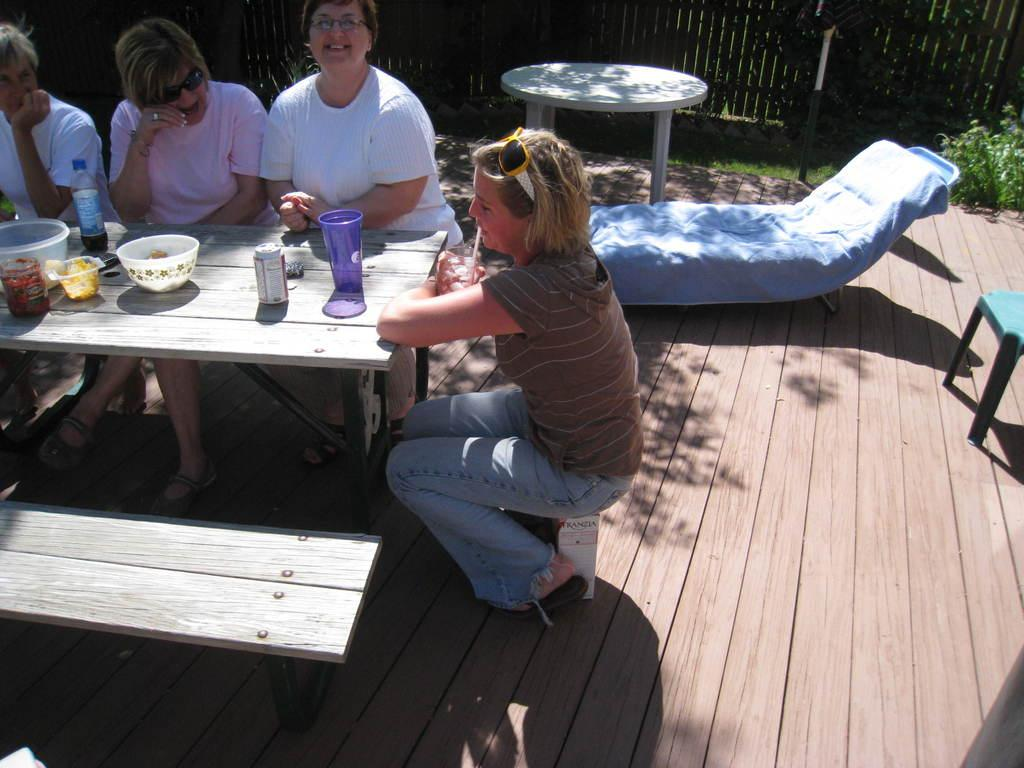How many people are in the image? There is a group of people in the image. What are the people doing in the image? The people are sitting on chairs. Where are the chairs located in relation to the table? The chairs are in front of a table. What can be seen on the table besides the chairs? There is a water bottle and other objects on the table. What type of force is being applied to the water bottle in the image? There is no indication of any force being applied to the water bottle in the image; it is simply sitting on the table. 